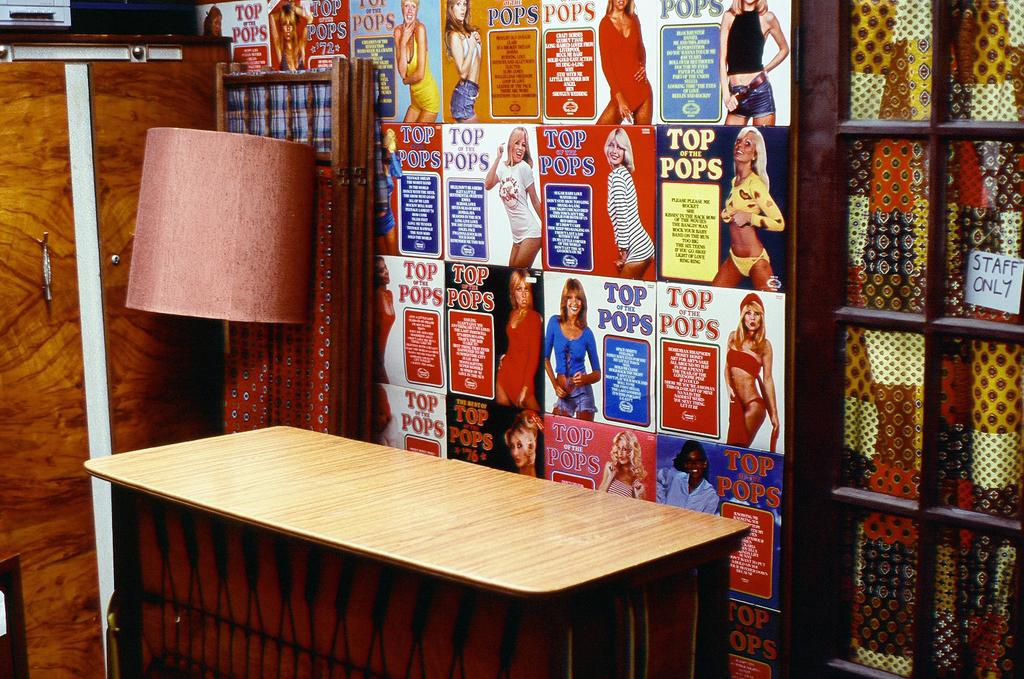<image>
Write a terse but informative summary of the picture. Desk in front of a wall full of posters with one saying TOP POPS. 